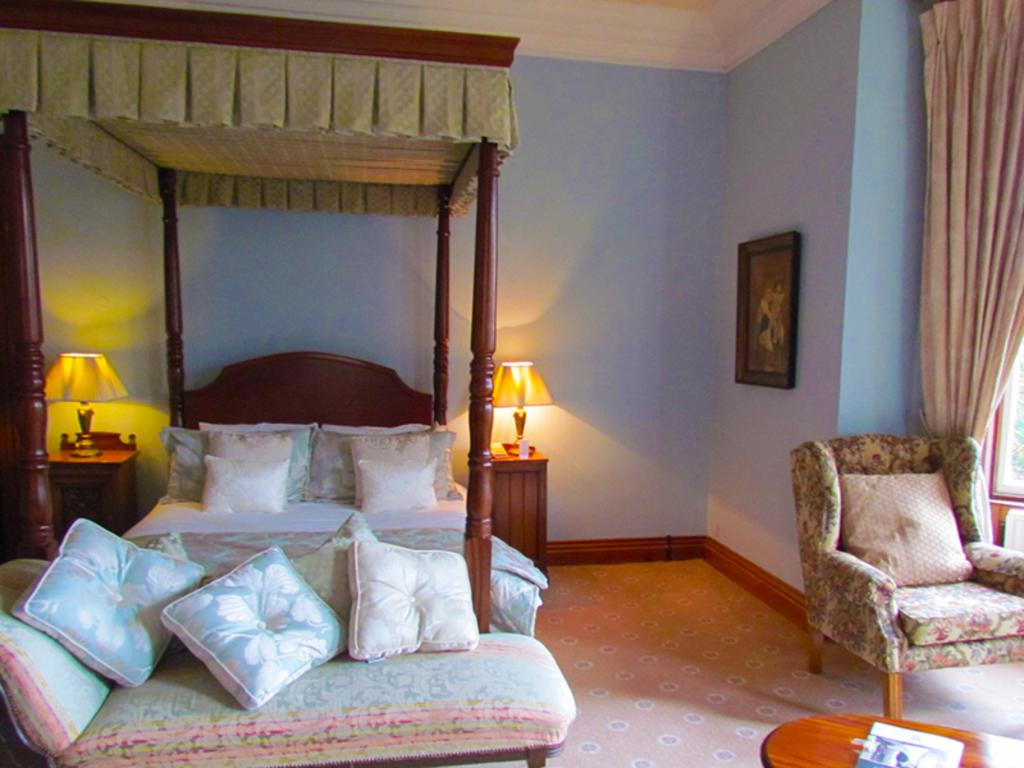What type of furniture is present in the room? There is a bed, a couch, a chair, and a table in the room. What items can be found on the furniture or around the room? There are pillows, a lamp, and a curtain in the room. Is there any decorative element on the wall? Yes, there is a frame attached to the wall in the room. What type of silk material is draped over the chair in the room? There is no silk material draped over the chair in the room; the chair is empty. Can you see a crow perched on the lamp in the room? There is no crow present in the room; the image only shows the furniture and decorative elements mentioned in the facts. 